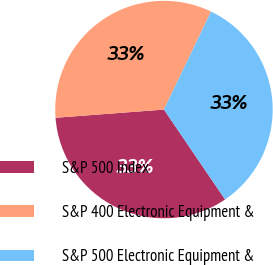Convert chart to OTSL. <chart><loc_0><loc_0><loc_500><loc_500><pie_chart><fcel>S&P 500 Index<fcel>S&P 400 Electronic Equipment &<fcel>S&P 500 Electronic Equipment &<nl><fcel>33.3%<fcel>33.33%<fcel>33.37%<nl></chart> 